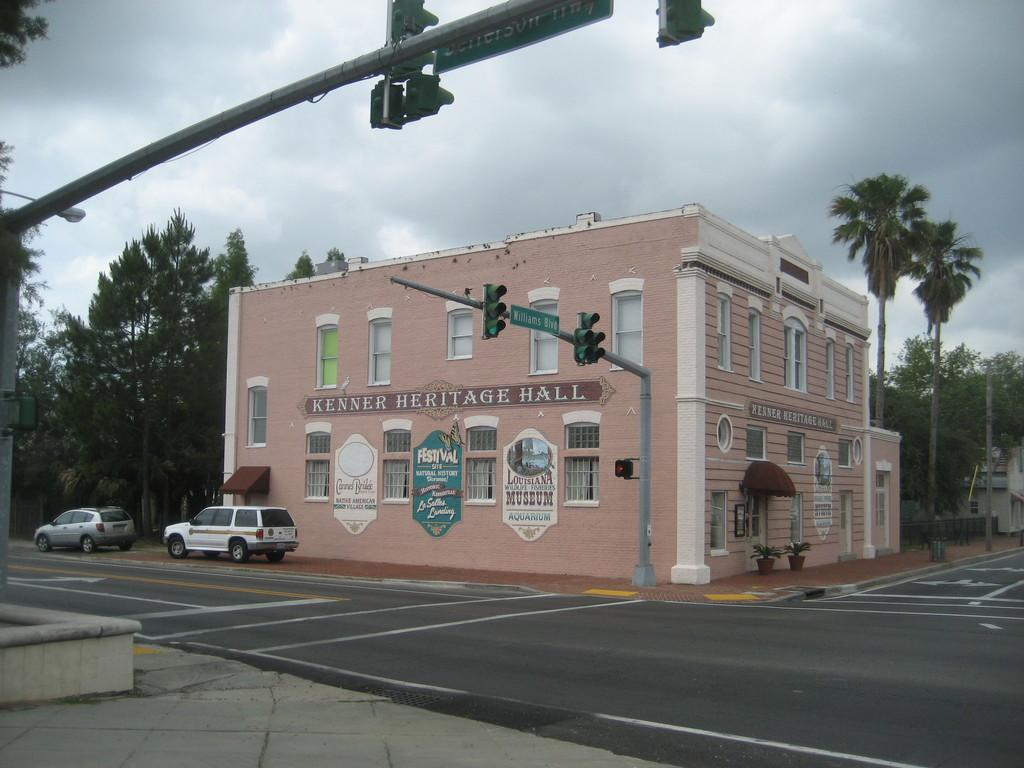What type of structure is visible in the image? There is a building in the image. What is located at the bottom of the image? There is a road at the bottom of the image. What is on the road in the image? There are cars on the road. What can be seen in the background of the image? There are trees in the background of the image. What is visible in the sky at the top of the image? There are clouds visible in the sky at the top of the image. Where can you find the store selling pies in the image? There is no store or pie mentioned in the image; it only features a building, a road, cars, trees, and clouds. How many cows are grazing in the background of the image? There are no cows present in the image; it only features trees in the background. 